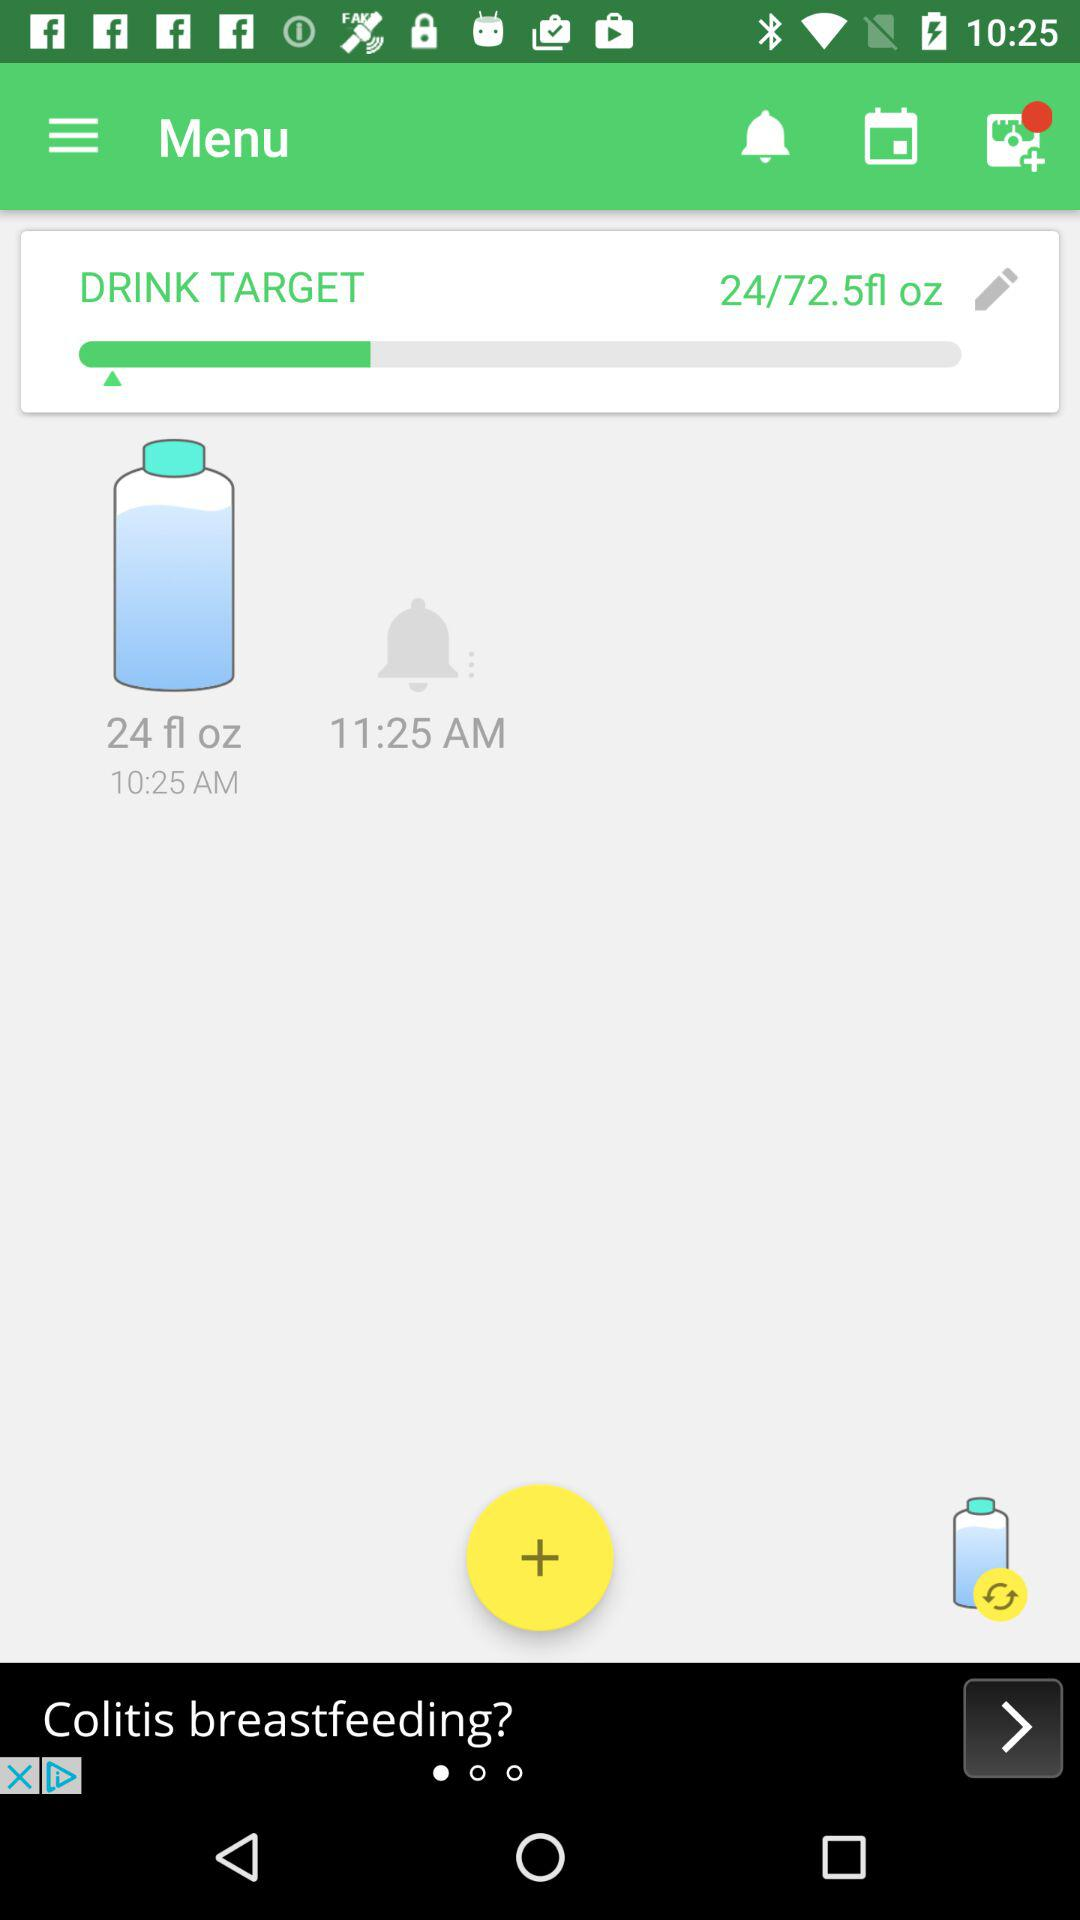How much water to drink at 10:25 am? The amount of water is 24 fl oz. 